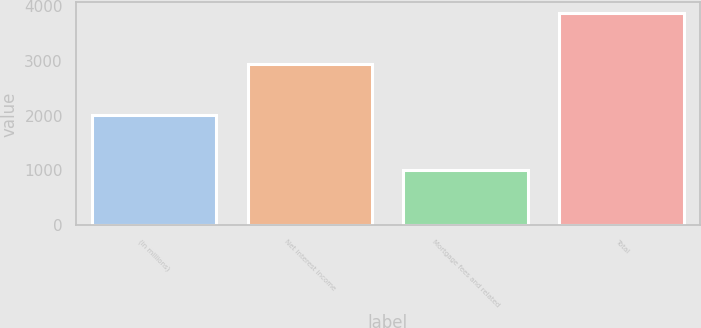Convert chart to OTSL. <chart><loc_0><loc_0><loc_500><loc_500><bar_chart><fcel>(in millions)<fcel>Net interest income<fcel>Mortgage fees and related<fcel>Total<nl><fcel>2004<fcel>2945<fcel>1012<fcel>3868<nl></chart> 